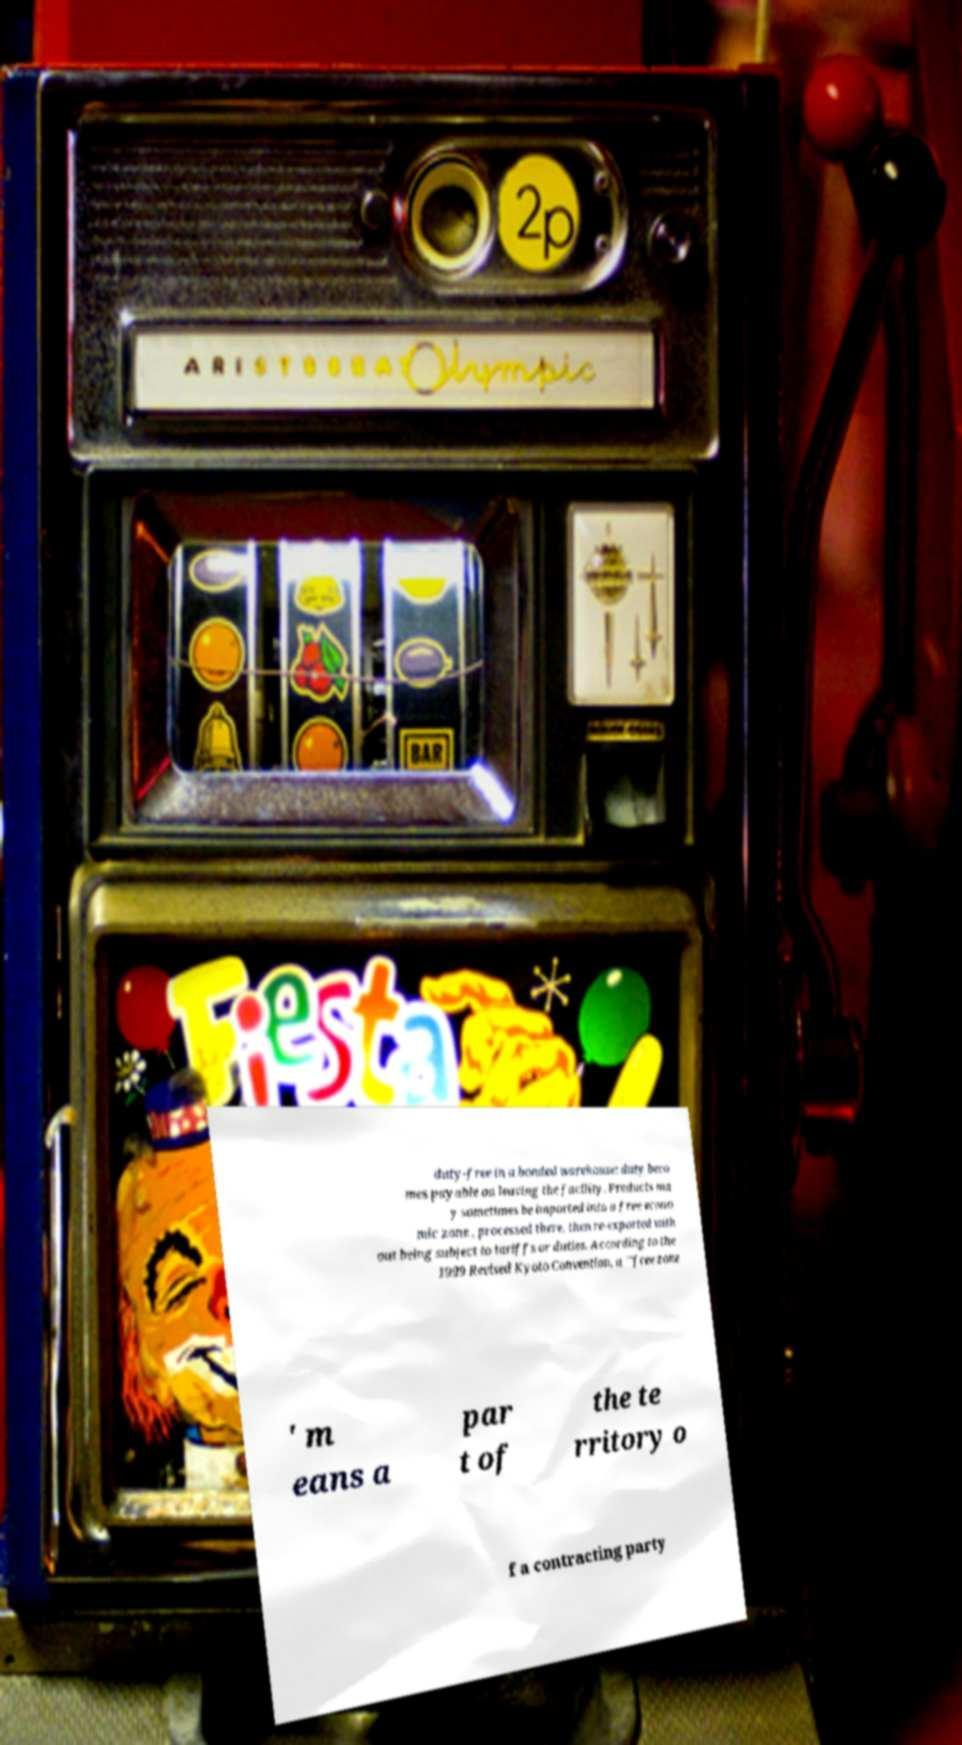Can you read and provide the text displayed in the image?This photo seems to have some interesting text. Can you extract and type it out for me? duty-free in a bonded warehouse: duty beco mes payable on leaving the facility. Products ma y sometimes be imported into a free econo mic zone , processed there, then re-exported with out being subject to tariffs or duties. According to the 1999 Revised Kyoto Convention, a "'free zone ' m eans a par t of the te rritory o f a contracting party 